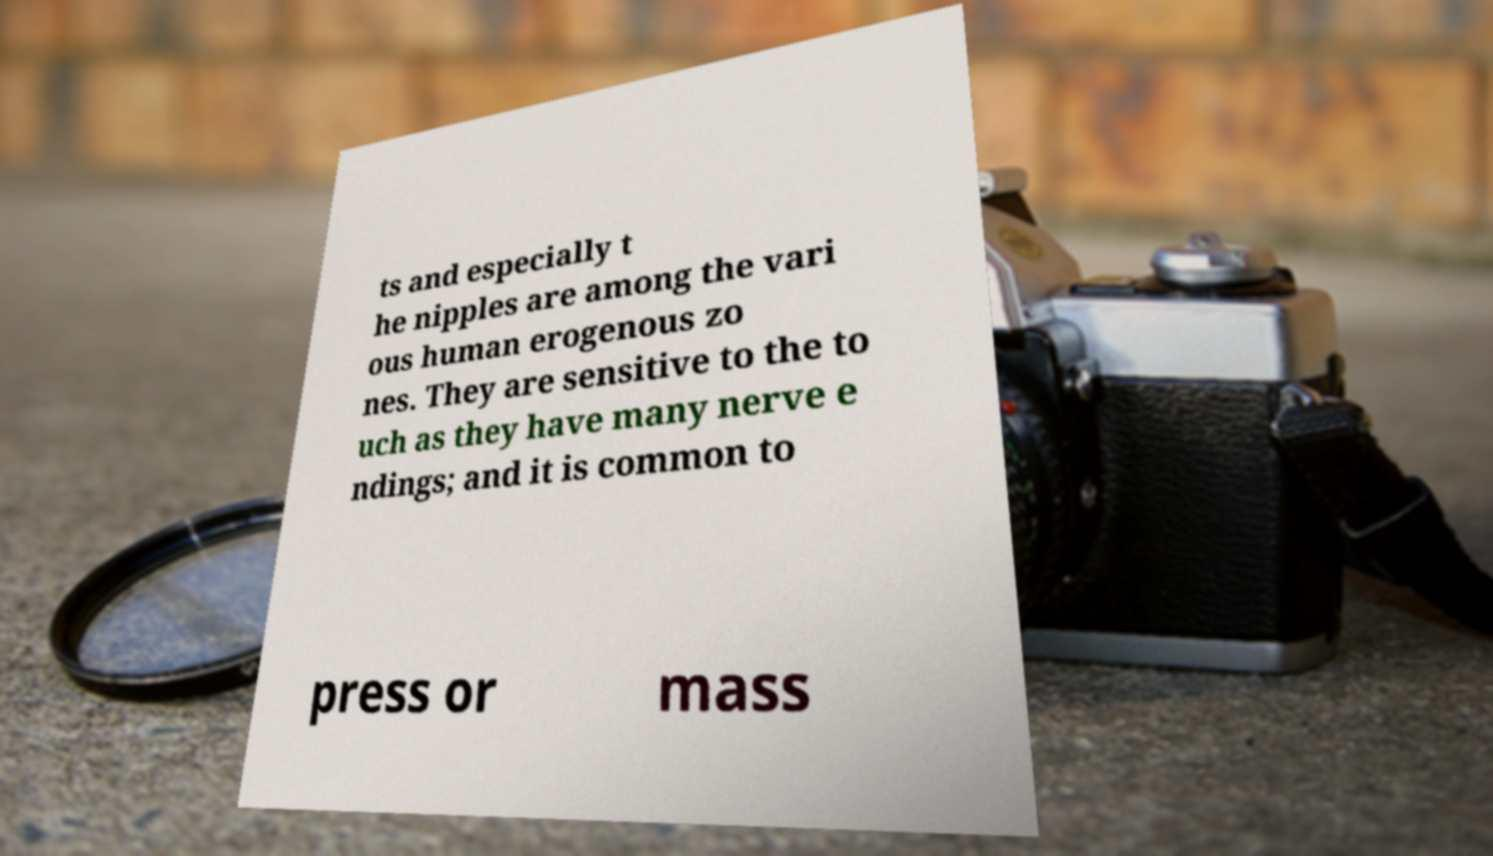For documentation purposes, I need the text within this image transcribed. Could you provide that? ts and especially t he nipples are among the vari ous human erogenous zo nes. They are sensitive to the to uch as they have many nerve e ndings; and it is common to press or mass 